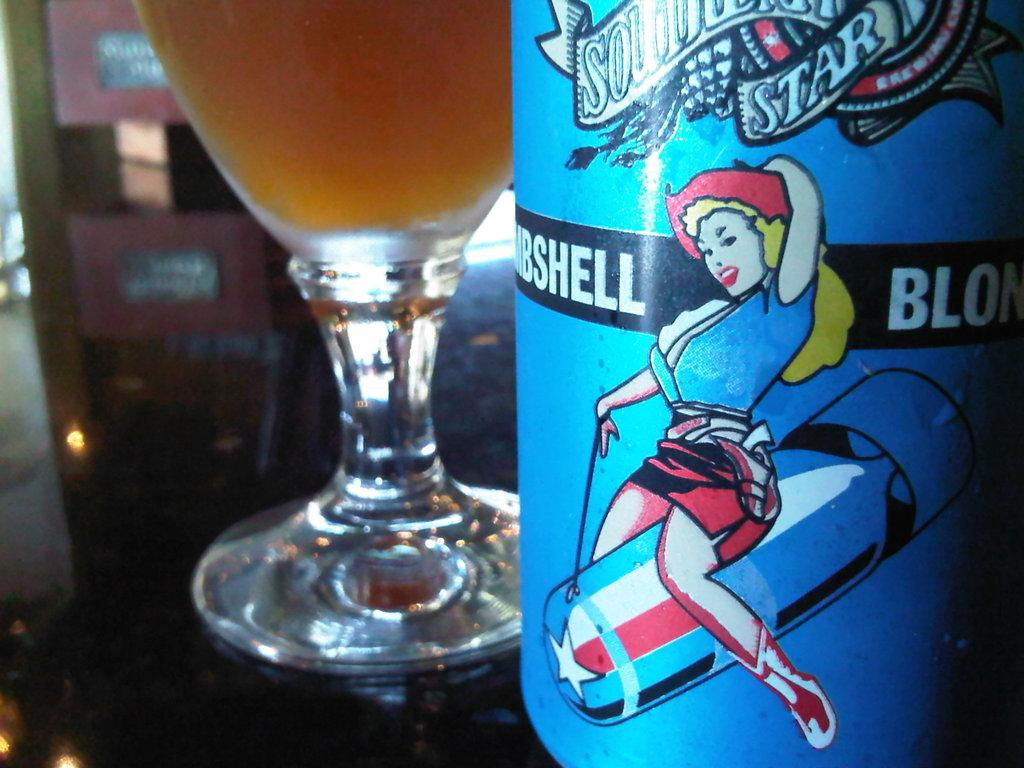<image>
Summarize the visual content of the image. A blue bottle has the word star on it and a glass next to it. 